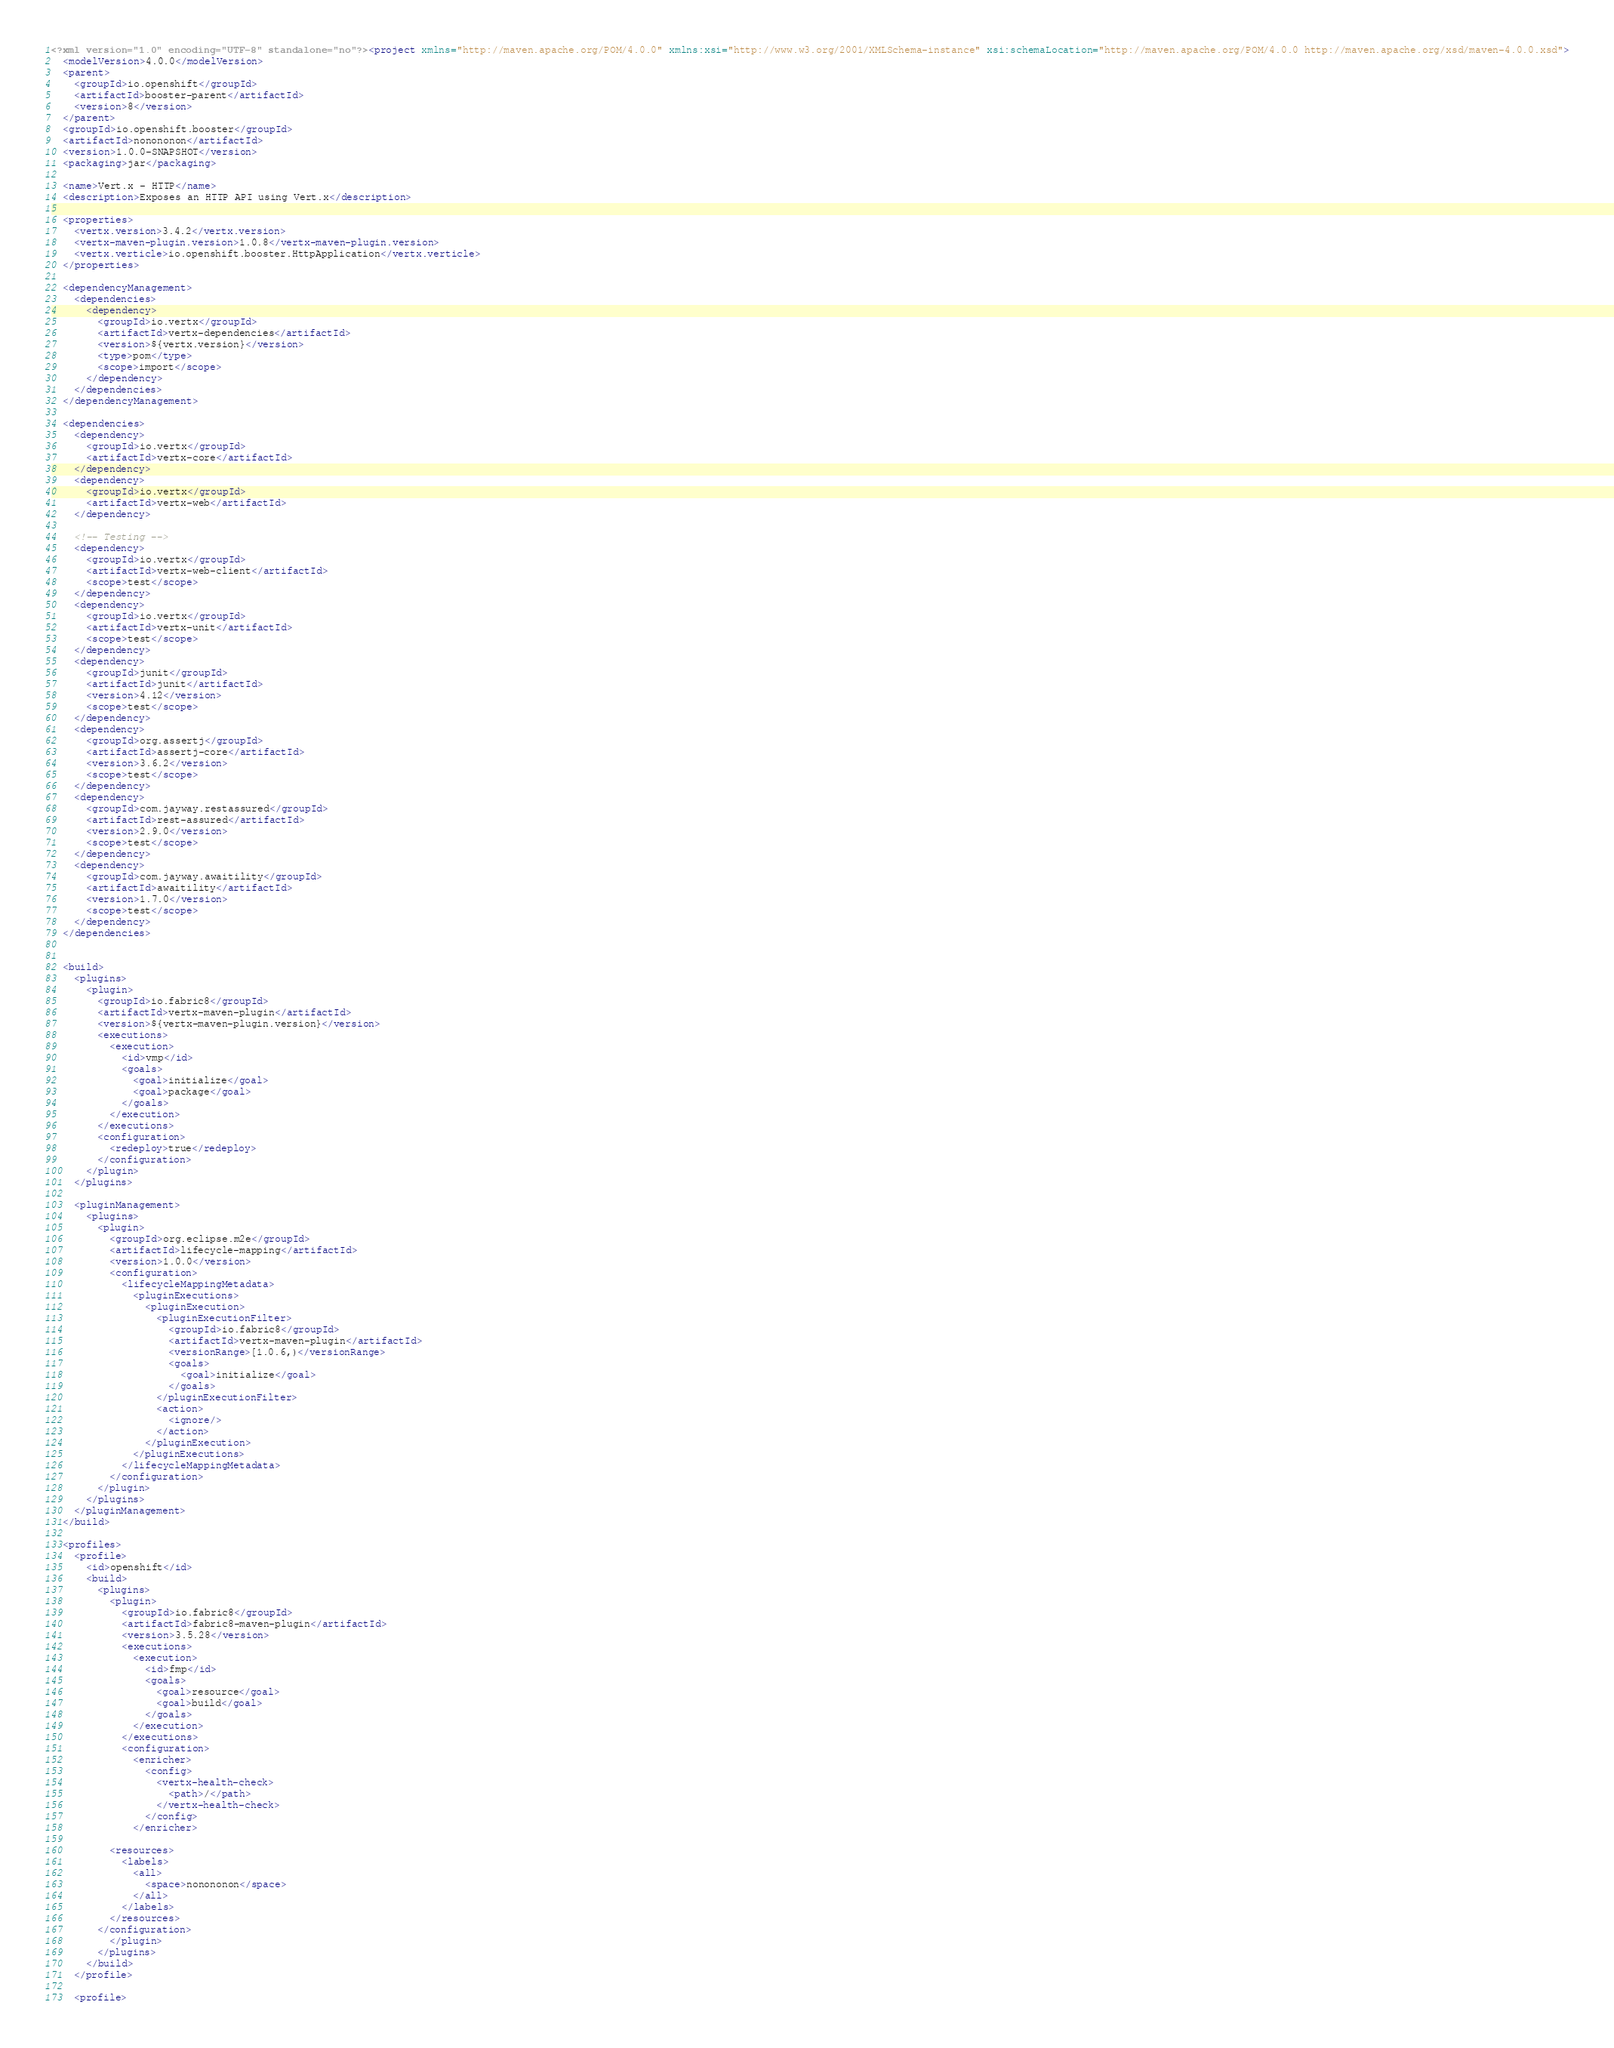Convert code to text. <code><loc_0><loc_0><loc_500><loc_500><_XML_><?xml version="1.0" encoding="UTF-8" standalone="no"?><project xmlns="http://maven.apache.org/POM/4.0.0" xmlns:xsi="http://www.w3.org/2001/XMLSchema-instance" xsi:schemaLocation="http://maven.apache.org/POM/4.0.0 http://maven.apache.org/xsd/maven-4.0.0.xsd">
  <modelVersion>4.0.0</modelVersion>
  <parent>
    <groupId>io.openshift</groupId>
    <artifactId>booster-parent</artifactId>
    <version>8</version>
  </parent>
  <groupId>io.openshift.booster</groupId>
  <artifactId>nonononon</artifactId>
  <version>1.0.0-SNAPSHOT</version>
  <packaging>jar</packaging>

  <name>Vert.x - HTTP</name>
  <description>Exposes an HTTP API using Vert.x</description>

  <properties>
    <vertx.version>3.4.2</vertx.version>
    <vertx-maven-plugin.version>1.0.8</vertx-maven-plugin.version>
    <vertx.verticle>io.openshift.booster.HttpApplication</vertx.verticle>
  </properties>

  <dependencyManagement>
    <dependencies>
      <dependency>
        <groupId>io.vertx</groupId>
        <artifactId>vertx-dependencies</artifactId>
        <version>${vertx.version}</version>
        <type>pom</type>
        <scope>import</scope>
      </dependency>
    </dependencies>
  </dependencyManagement>

  <dependencies>
    <dependency>
      <groupId>io.vertx</groupId>
      <artifactId>vertx-core</artifactId>
    </dependency>
    <dependency>
      <groupId>io.vertx</groupId>
      <artifactId>vertx-web</artifactId>
    </dependency>

    <!-- Testing -->
    <dependency>
      <groupId>io.vertx</groupId>
      <artifactId>vertx-web-client</artifactId>
      <scope>test</scope>
    </dependency>
    <dependency>
      <groupId>io.vertx</groupId>
      <artifactId>vertx-unit</artifactId>
      <scope>test</scope>
    </dependency>
    <dependency>
      <groupId>junit</groupId>
      <artifactId>junit</artifactId>
      <version>4.12</version>
      <scope>test</scope>
    </dependency>
    <dependency>
      <groupId>org.assertj</groupId>
      <artifactId>assertj-core</artifactId>
      <version>3.6.2</version>
      <scope>test</scope>
    </dependency>
    <dependency>
      <groupId>com.jayway.restassured</groupId>
      <artifactId>rest-assured</artifactId>
      <version>2.9.0</version>
      <scope>test</scope>
    </dependency>
    <dependency>
      <groupId>com.jayway.awaitility</groupId>
      <artifactId>awaitility</artifactId>
      <version>1.7.0</version>
      <scope>test</scope>
    </dependency>
  </dependencies>


  <build>
    <plugins>
      <plugin>
        <groupId>io.fabric8</groupId>
        <artifactId>vertx-maven-plugin</artifactId>
        <version>${vertx-maven-plugin.version}</version>
        <executions>
          <execution>
            <id>vmp</id>
            <goals>
              <goal>initialize</goal>
              <goal>package</goal>
            </goals>
          </execution>
        </executions>
        <configuration>
          <redeploy>true</redeploy>
        </configuration>
      </plugin>
    </plugins>

    <pluginManagement>
      <plugins>
        <plugin>
          <groupId>org.eclipse.m2e</groupId>
          <artifactId>lifecycle-mapping</artifactId>
          <version>1.0.0</version>
          <configuration>
            <lifecycleMappingMetadata>
              <pluginExecutions>
                <pluginExecution>
                  <pluginExecutionFilter>
                    <groupId>io.fabric8</groupId>
                    <artifactId>vertx-maven-plugin</artifactId>
                    <versionRange>[1.0.6,)</versionRange>
                    <goals>
                      <goal>initialize</goal>
                    </goals>
                  </pluginExecutionFilter>
                  <action>
                    <ignore/>
                  </action>
                </pluginExecution>
              </pluginExecutions>
            </lifecycleMappingMetadata>
          </configuration>
        </plugin>
      </plugins>
    </pluginManagement>
  </build>

  <profiles>
    <profile>
      <id>openshift</id>
      <build>
        <plugins>
          <plugin>
            <groupId>io.fabric8</groupId>
            <artifactId>fabric8-maven-plugin</artifactId>
            <version>3.5.28</version>
            <executions>
              <execution>
                <id>fmp</id>
                <goals>
                  <goal>resource</goal>
                  <goal>build</goal>
                </goals>
              </execution>
            </executions>
            <configuration>
              <enricher>
                <config>
                  <vertx-health-check>
                    <path>/</path>
                  </vertx-health-check>
                </config>
              </enricher>
            
          <resources>
            <labels>
              <all>
                <space>nonononon</space>
              </all>
            </labels>
          </resources>
        </configuration>
          </plugin>
        </plugins>
      </build>
    </profile>

    <profile></code> 